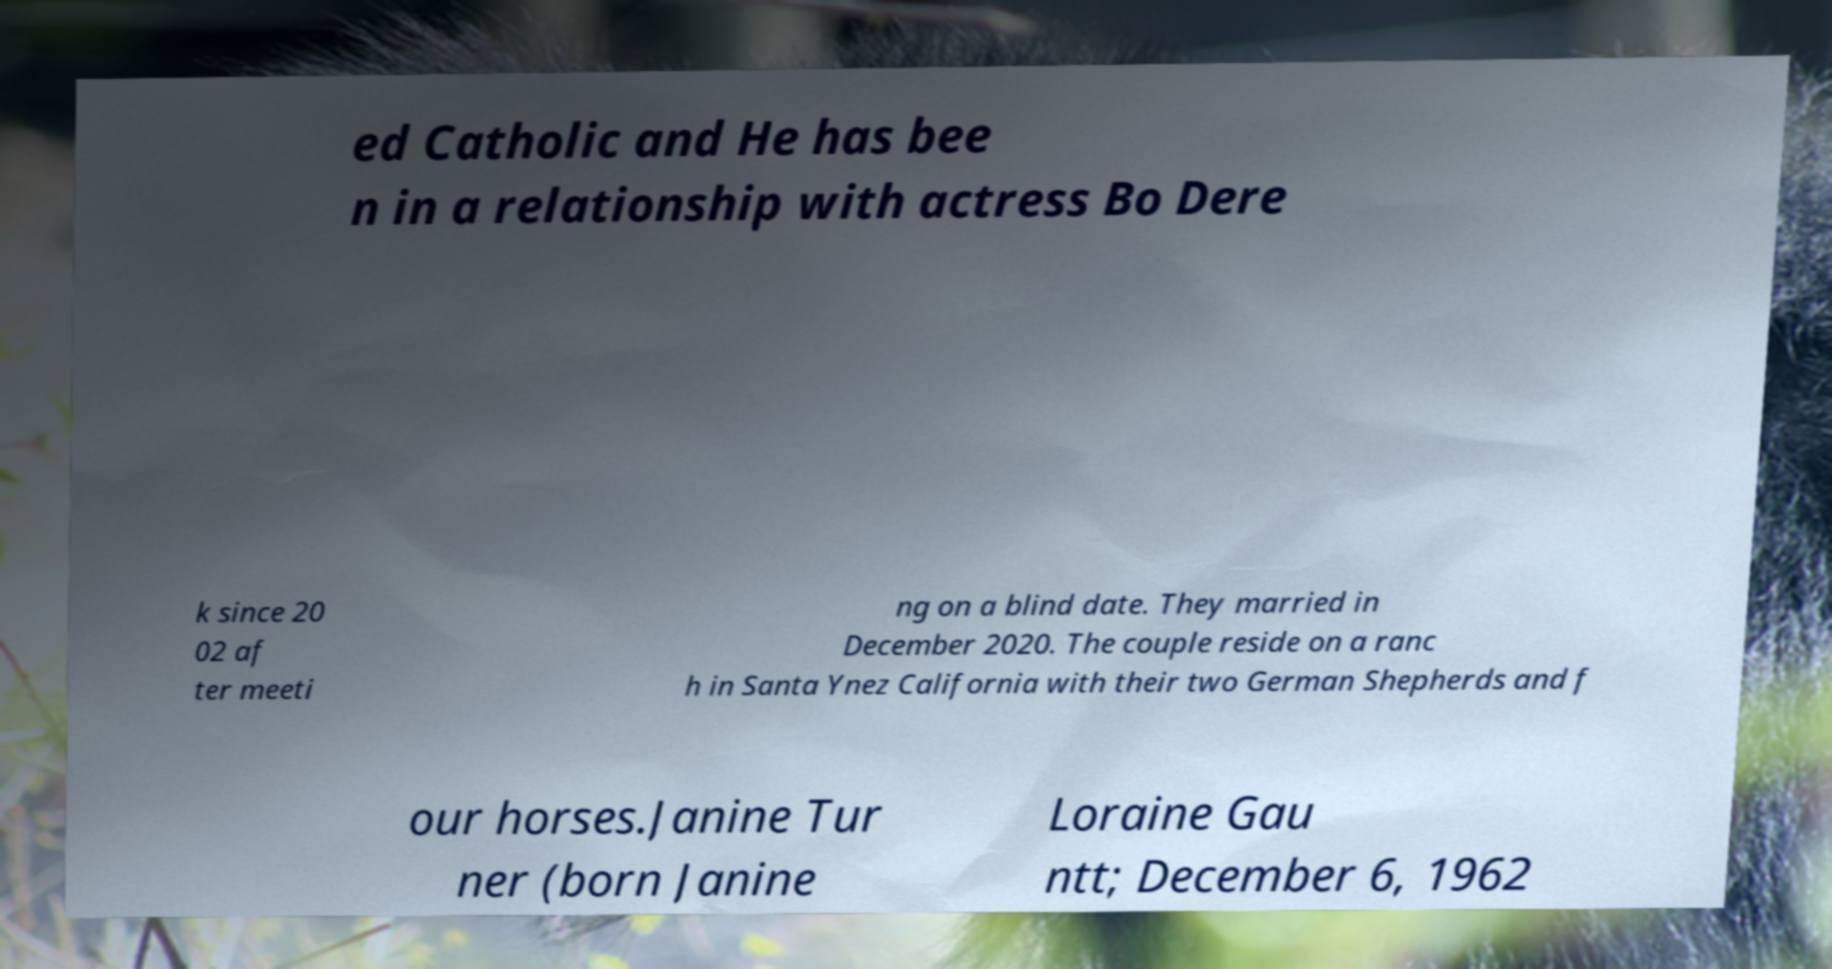For documentation purposes, I need the text within this image transcribed. Could you provide that? ed Catholic and He has bee n in a relationship with actress Bo Dere k since 20 02 af ter meeti ng on a blind date. They married in December 2020. The couple reside on a ranc h in Santa Ynez California with their two German Shepherds and f our horses.Janine Tur ner (born Janine Loraine Gau ntt; December 6, 1962 